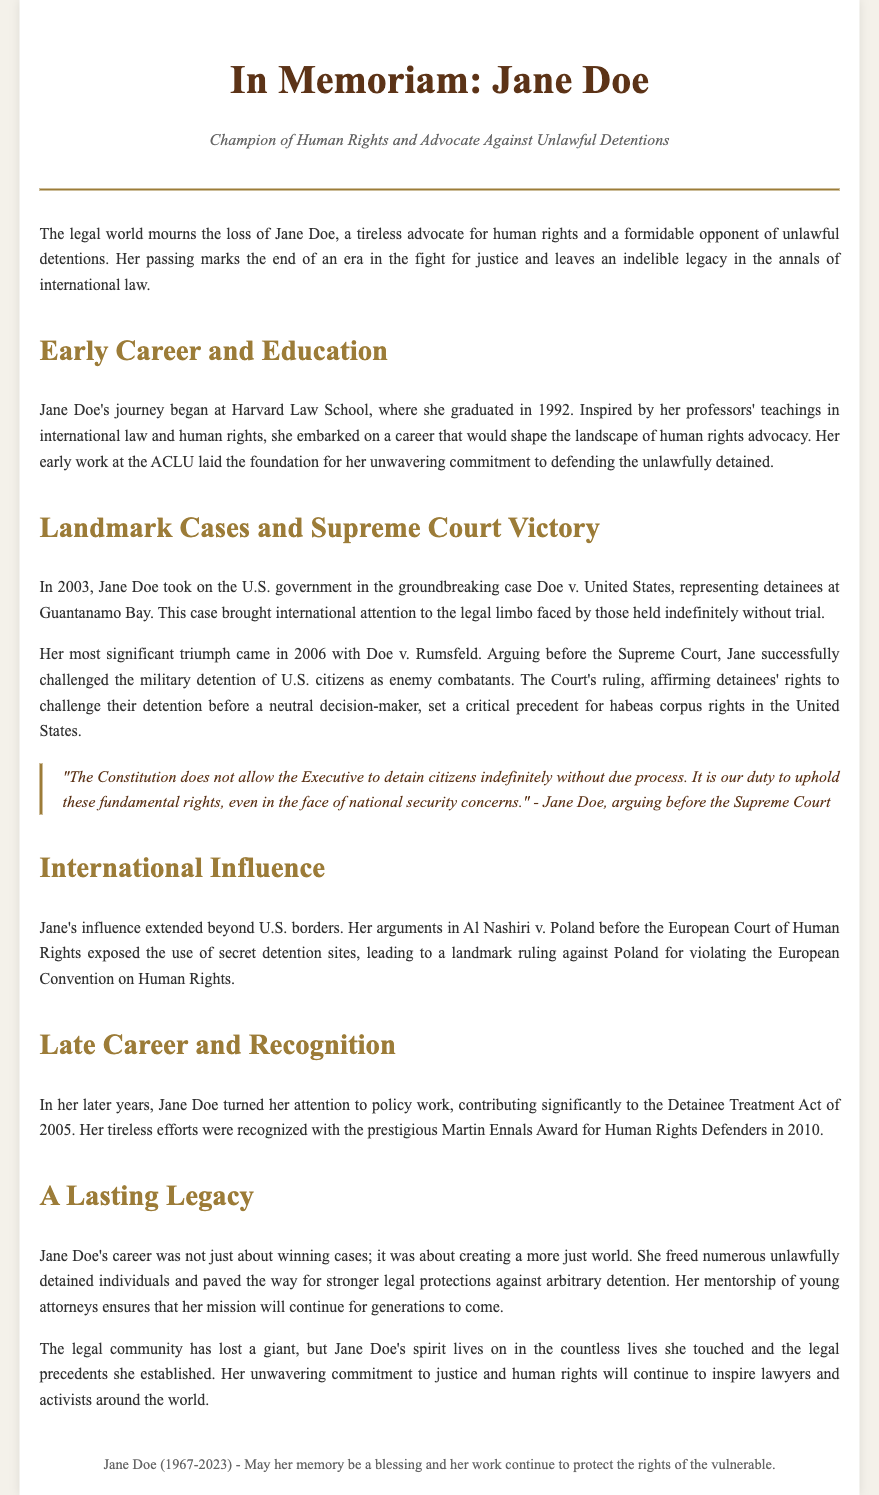What year did Jane Doe graduate from Harvard Law School? The document states that Jane Doe graduated in 1992.
Answer: 1992 What case did Jane Doe argue in front of the Supreme Court in 2006? The document mentions that she argued Doe v. Rumsfeld in 2006.
Answer: Doe v. Rumsfeld What award did Jane Doe receive in 2010? The obituary indicates she received the Martin Ennals Award for Human Rights Defenders in 2010.
Answer: Martin Ennals Award What is the main focus of Jane Doe's advocacy work? The document describes her work as primarily against unlawful detentions.
Answer: Unlawful detentions Which international court did Jane Doe influence with her arguments? According to the document, her influence extended to the European Court of Human Rights.
Answer: European Court of Human Rights What was Jane Doe's role in the case of Doe v. United States? The document states that she represented detainees at Guantanamo Bay in this case.
Answer: Represented detainees What legal concerns did Jane Doe's work address? The obituary emphasizes her commitment to due process and habeas corpus rights.
Answer: Due process and habeas corpus rights Who did Jane Doe mentor towards the end of her career? The document highlights her mentorship of young attorneys as part of her legacy.
Answer: Young attorneys 